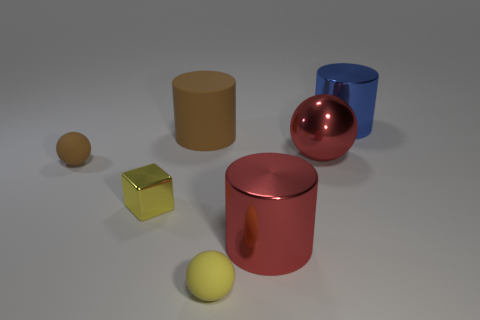There is a small object that is the same color as the large matte cylinder; what is it made of?
Your answer should be compact. Rubber. Is there a tiny brown rubber thing that has the same shape as the large blue shiny thing?
Offer a very short reply. No. Does the big brown object right of the yellow metallic thing have the same material as the big cylinder that is in front of the big red ball?
Offer a very short reply. No. There is a metallic cylinder in front of the rubber object behind the tiny thing behind the yellow metallic object; what is its size?
Offer a terse response. Large. There is a yellow block that is the same size as the yellow ball; what is its material?
Keep it short and to the point. Metal. Is there a red object that has the same size as the yellow ball?
Offer a terse response. No. Is the shape of the large matte thing the same as the big blue metal object?
Give a very brief answer. Yes. Are there any big blue metal objects that are on the right side of the rubber sphere in front of the brown rubber thing that is in front of the large brown cylinder?
Keep it short and to the point. Yes. What number of other things are there of the same color as the shiny sphere?
Keep it short and to the point. 1. Does the metallic object behind the big matte cylinder have the same size as the metal object in front of the block?
Offer a very short reply. Yes. 